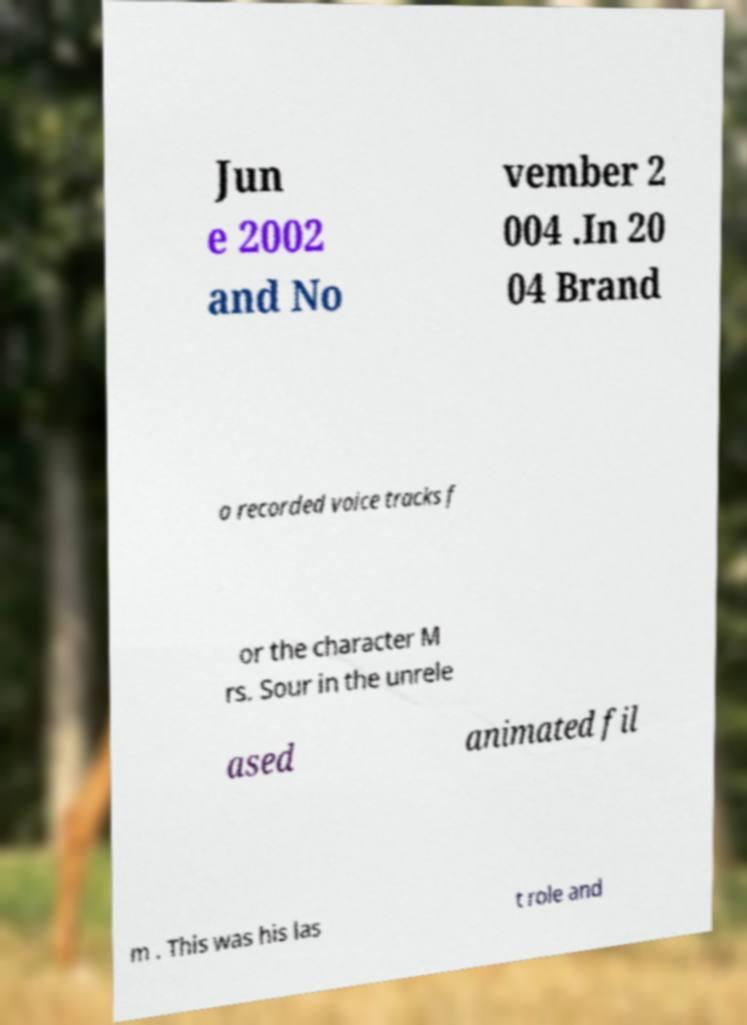Can you read and provide the text displayed in the image?This photo seems to have some interesting text. Can you extract and type it out for me? Jun e 2002 and No vember 2 004 .In 20 04 Brand o recorded voice tracks f or the character M rs. Sour in the unrele ased animated fil m . This was his las t role and 